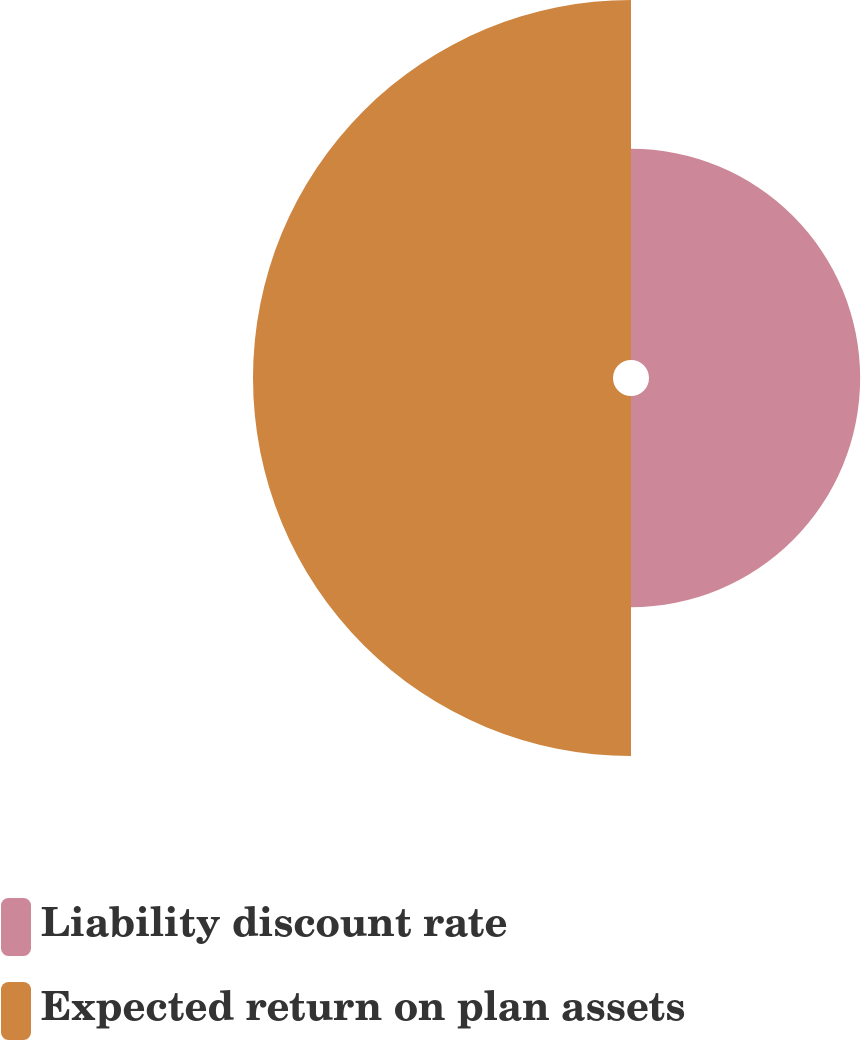Convert chart. <chart><loc_0><loc_0><loc_500><loc_500><pie_chart><fcel>Liability discount rate<fcel>Expected return on plan assets<nl><fcel>36.97%<fcel>63.03%<nl></chart> 